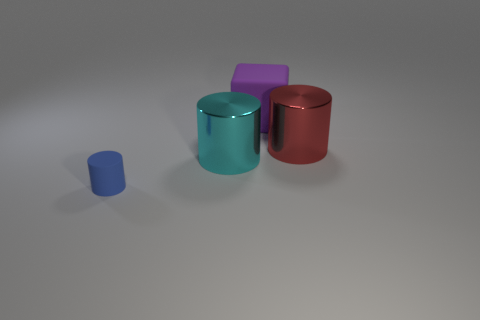Is the number of blue cylinders greater than the number of tiny cubes?
Provide a short and direct response. Yes. Is the shape of the big object that is on the left side of the big purple rubber cube the same as  the blue thing?
Offer a terse response. Yes. What number of matte things are on the right side of the blue rubber cylinder and in front of the red shiny cylinder?
Provide a short and direct response. 0. What number of big red objects are the same shape as the tiny blue object?
Your answer should be very brief. 1. What is the color of the large metallic object that is left of the cylinder to the right of the purple object?
Offer a terse response. Cyan. Is the shape of the tiny rubber object the same as the matte thing behind the big red shiny object?
Ensure brevity in your answer.  No. What is the material of the large object that is in front of the big cylinder right of the large object that is in front of the red object?
Offer a terse response. Metal. Are there any blue cylinders of the same size as the cyan metallic cylinder?
Give a very brief answer. No. The thing that is made of the same material as the big cyan cylinder is what size?
Your response must be concise. Large. The large purple rubber object has what shape?
Provide a short and direct response. Cube. 